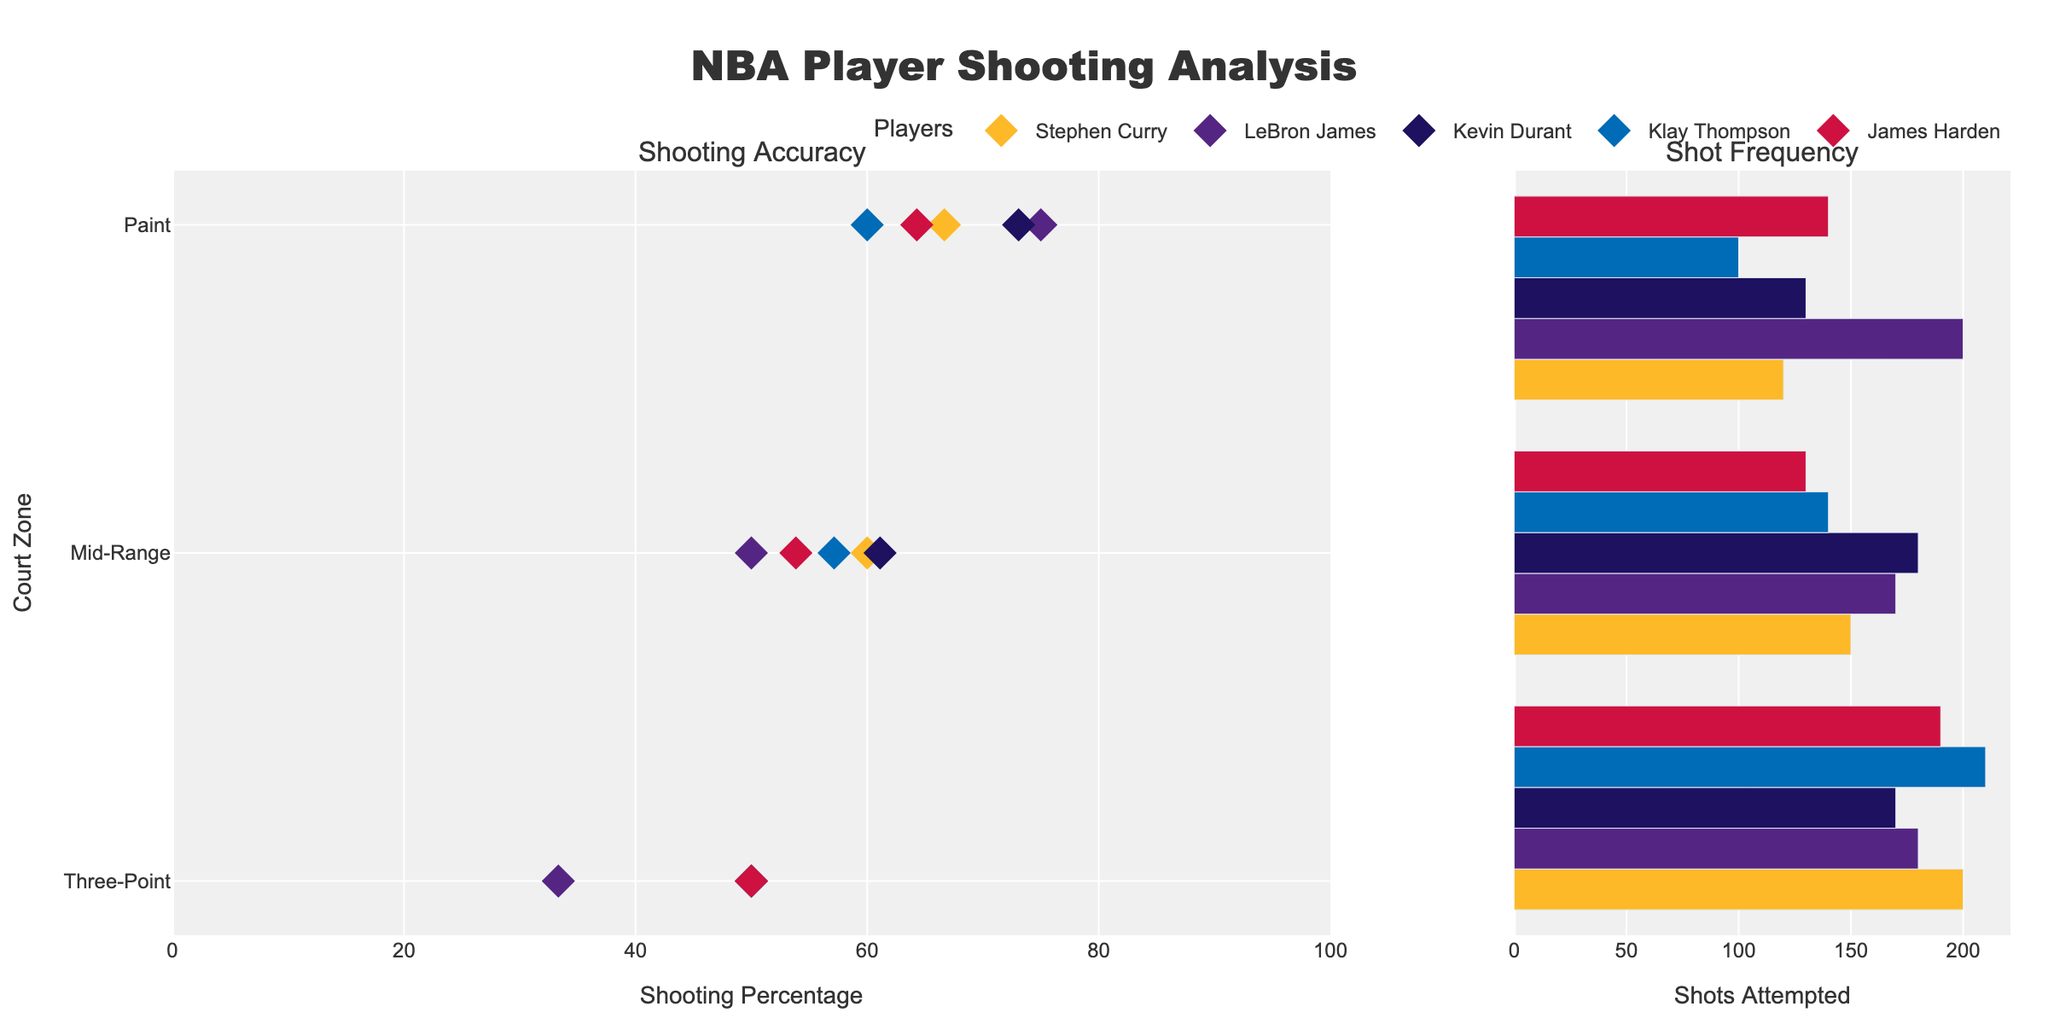What is the title of the plot? The title of the plot is prominently displayed at the top center of the figure. It reads 'NBA Player Shooting Analysis'.
Answer: NBA Player Shooting Analysis Which player has the highest shooting percentage in the Paint zone? Look at the dots in the Paint zone on the left sub-plot and compare their positions. Kevin Durant's dot is the highest in this zone, indicating he has the highest shooting percentage.
Answer: Kevin Durant How many shots did James Harden attempt from the Mid-Range zone? Look at the height of the bar representing James Harden in the Mid-Range zone on the right sub-plot. The length of the bar corresponds to the number of shots attempted.
Answer: 130 Which player has the smallest difference in shooting accuracy between the Three-Point zone and the Mid-Range zone? Compare the distances between the shooting percentage points of each player in the Three-Point and Mid-Range zones on the left sub-plot. Stephen Curry has the smallest difference.
Answer: Stephen Curry Who attempted the most shots overall? Sum the lengths of the bars for each player across all zones on the right sub-plot. LeBron James has the highest total number of shots attempted.
Answer: LeBron James Between Stephen Curry and Klay Thompson, who has a higher shooting percentage in the Mid-Range zone? Compare the positions of the dots for Stephen Curry and Klay Thompson in the Mid-Range zone on the left sub-plot. Stephen Curry's dot is higher.
Answer: Stephen Curry What is the overall trend in shooting percentage as the distance from the basket decreases? Observe the positions of dots from left to right across the zones on the left sub-plot. Generally, shooting percentages increase as the distance from the basket decreases.
Answer: Increases Which zone has the highest shooting frequency for Stephen Curry? Compare the lengths of the bars for Stephen Curry across all zones on the right sub-plot. The longest bar is in the Three-Point zone.
Answer: Three-Point How does LeBron James' shooting accuracy in the Paint zone compare to Kevin Durant's? Compare the positions of their dots in the Paint zone on the left sub-plot. LeBron James' dot is lower than Kevin Durant's.
Answer: Lower What is the average shooting percentage across all zones for James Harden? Calculate the shooting percentages for James Harden in each zone, then find the average: (50% + 53.85% + 64.29%) / 3 ≈ 56.05%.
Answer: 56.05% 